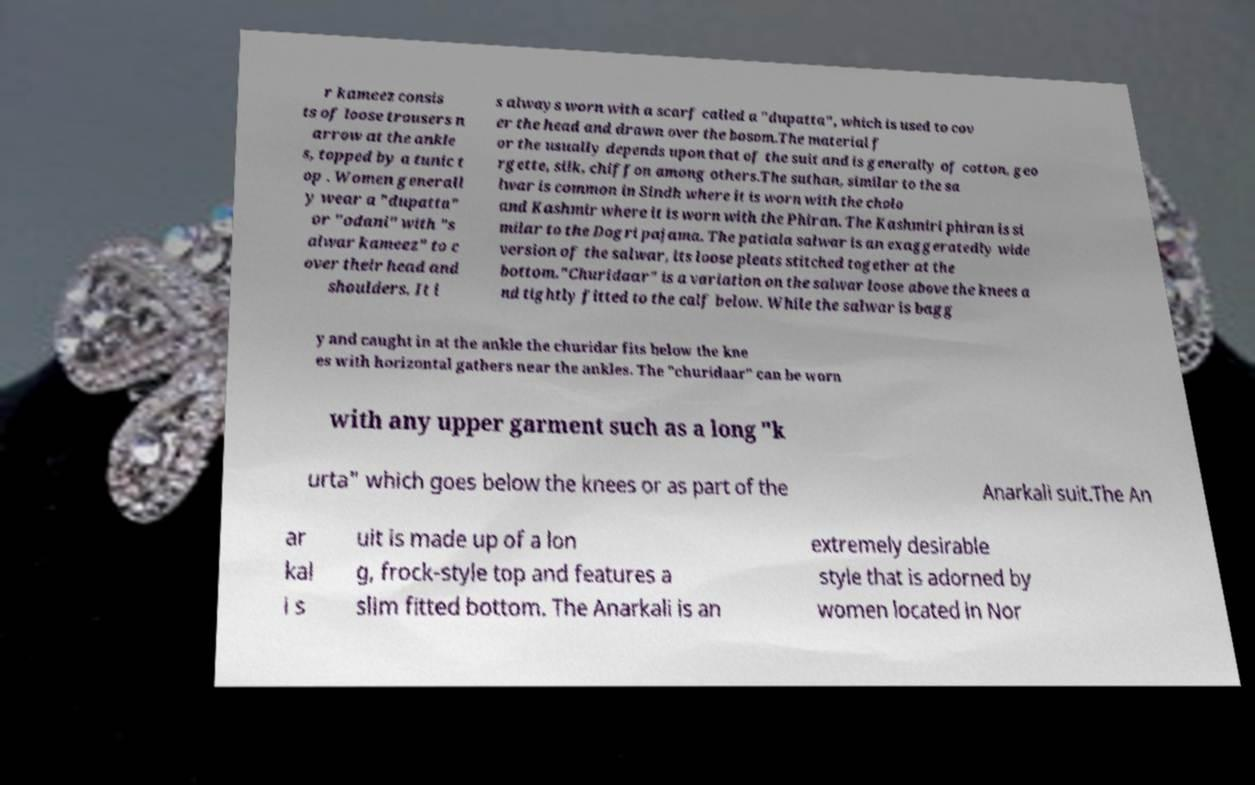What messages or text are displayed in this image? I need them in a readable, typed format. r kameez consis ts of loose trousers n arrow at the ankle s, topped by a tunic t op . Women generall y wear a "dupatta" or "odani" with "s alwar kameez" to c over their head and shoulders. It i s always worn with a scarf called a "dupatta", which is used to cov er the head and drawn over the bosom.The material f or the usually depends upon that of the suit and is generally of cotton, geo rgette, silk, chiffon among others.The suthan, similar to the sa lwar is common in Sindh where it is worn with the cholo and Kashmir where it is worn with the Phiran. The Kashmiri phiran is si milar to the Dogri pajama. The patiala salwar is an exaggeratedly wide version of the salwar, its loose pleats stitched together at the bottom."Churidaar" is a variation on the salwar loose above the knees a nd tightly fitted to the calf below. While the salwar is bagg y and caught in at the ankle the churidar fits below the kne es with horizontal gathers near the ankles. The "churidaar" can be worn with any upper garment such as a long "k urta" which goes below the knees or as part of the Anarkali suit.The An ar kal i s uit is made up of a lon g, frock-style top and features a slim fitted bottom. The Anarkali is an extremely desirable style that is adorned by women located in Nor 